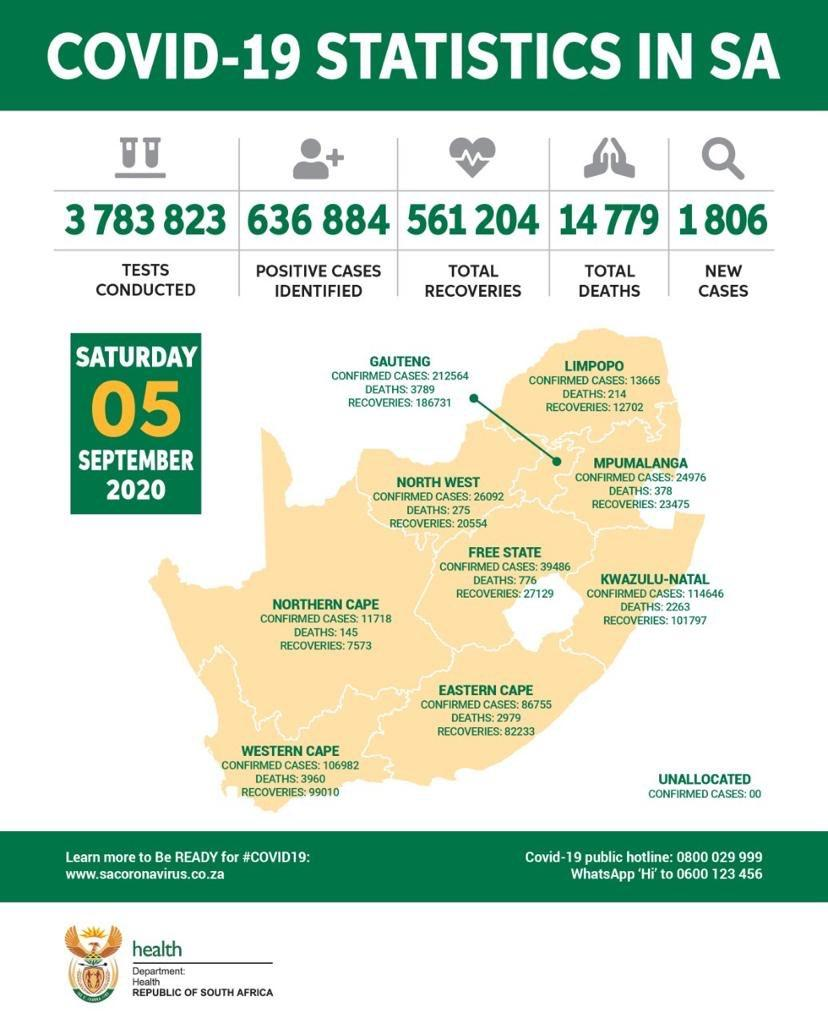Outline some significant characteristics in this image. The Northern Cape province of South Africa has reported the lowest number of confirmed cases of the COVID-19 pandemic, as of the latest reported data. The Eastern Cape has reported a lower number of confirmed COVID-19 cases compared to the Northern Cape. The number of confirmed cases in Northern Cape is 75037, while the number in Eastern Cape is 75037. The Western Cape has reported the highest number of deaths in South Africa. In how many states have the number of recovered COVID-19 cases crossed 100,000? 